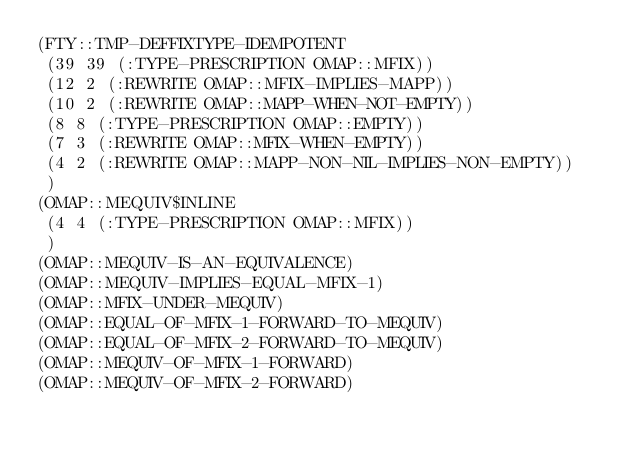<code> <loc_0><loc_0><loc_500><loc_500><_Lisp_>(FTY::TMP-DEFFIXTYPE-IDEMPOTENT
 (39 39 (:TYPE-PRESCRIPTION OMAP::MFIX))
 (12 2 (:REWRITE OMAP::MFIX-IMPLIES-MAPP))
 (10 2 (:REWRITE OMAP::MAPP-WHEN-NOT-EMPTY))
 (8 8 (:TYPE-PRESCRIPTION OMAP::EMPTY))
 (7 3 (:REWRITE OMAP::MFIX-WHEN-EMPTY))
 (4 2 (:REWRITE OMAP::MAPP-NON-NIL-IMPLIES-NON-EMPTY))
 )
(OMAP::MEQUIV$INLINE
 (4 4 (:TYPE-PRESCRIPTION OMAP::MFIX))
 )
(OMAP::MEQUIV-IS-AN-EQUIVALENCE)
(OMAP::MEQUIV-IMPLIES-EQUAL-MFIX-1)
(OMAP::MFIX-UNDER-MEQUIV)
(OMAP::EQUAL-OF-MFIX-1-FORWARD-TO-MEQUIV)
(OMAP::EQUAL-OF-MFIX-2-FORWARD-TO-MEQUIV)
(OMAP::MEQUIV-OF-MFIX-1-FORWARD)
(OMAP::MEQUIV-OF-MFIX-2-FORWARD)
</code> 